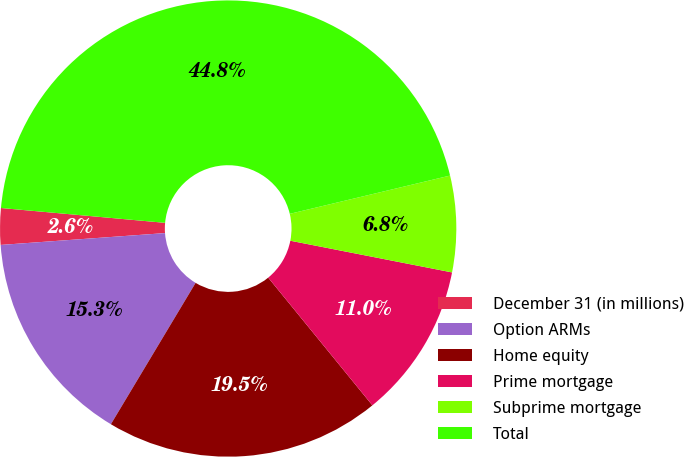Convert chart to OTSL. <chart><loc_0><loc_0><loc_500><loc_500><pie_chart><fcel>December 31 (in millions)<fcel>Option ARMs<fcel>Home equity<fcel>Prime mortgage<fcel>Subprime mortgage<fcel>Total<nl><fcel>2.58%<fcel>15.26%<fcel>19.48%<fcel>11.03%<fcel>6.81%<fcel>44.83%<nl></chart> 